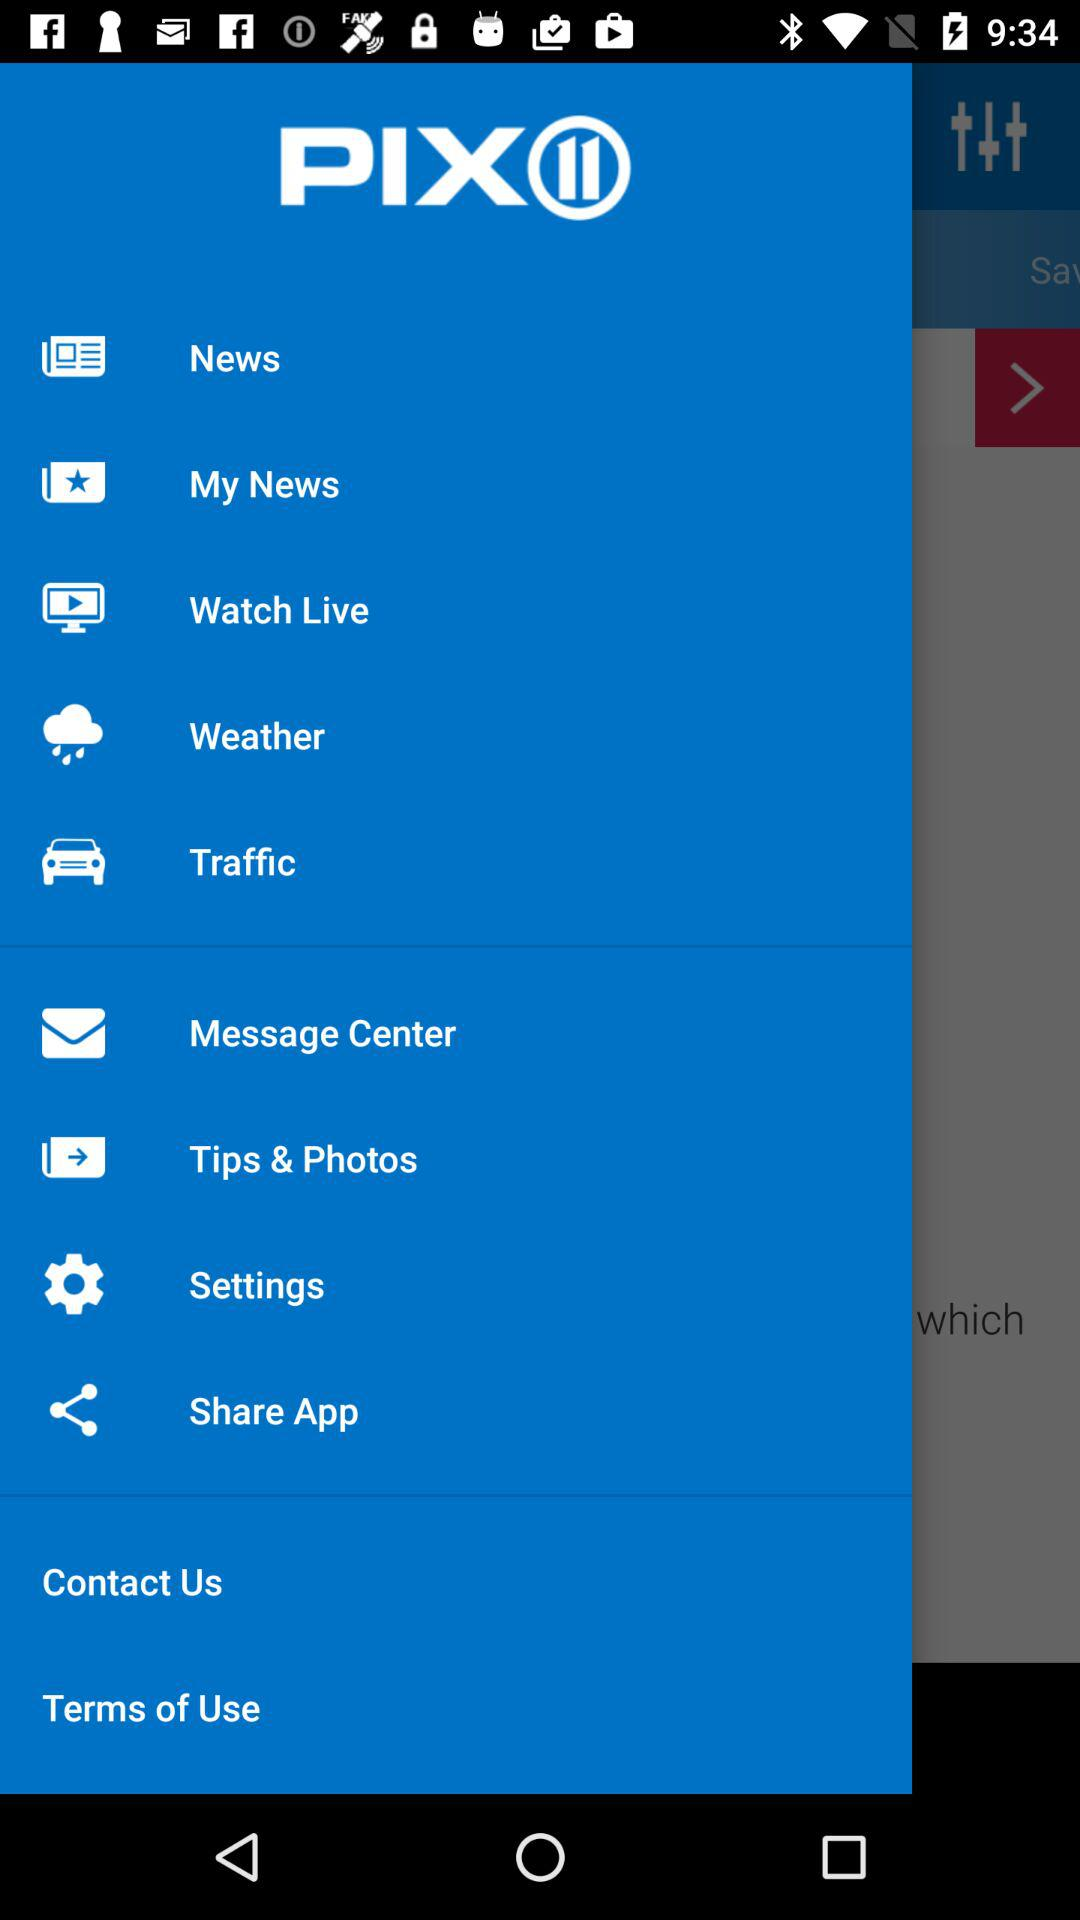How many notifications are there in "Message Center"?
When the provided information is insufficient, respond with <no answer>. <no answer> 